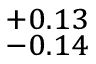Convert formula to latex. <formula><loc_0><loc_0><loc_500><loc_500>^ { + 0 . 1 3 } _ { - 0 . 1 4 }</formula> 